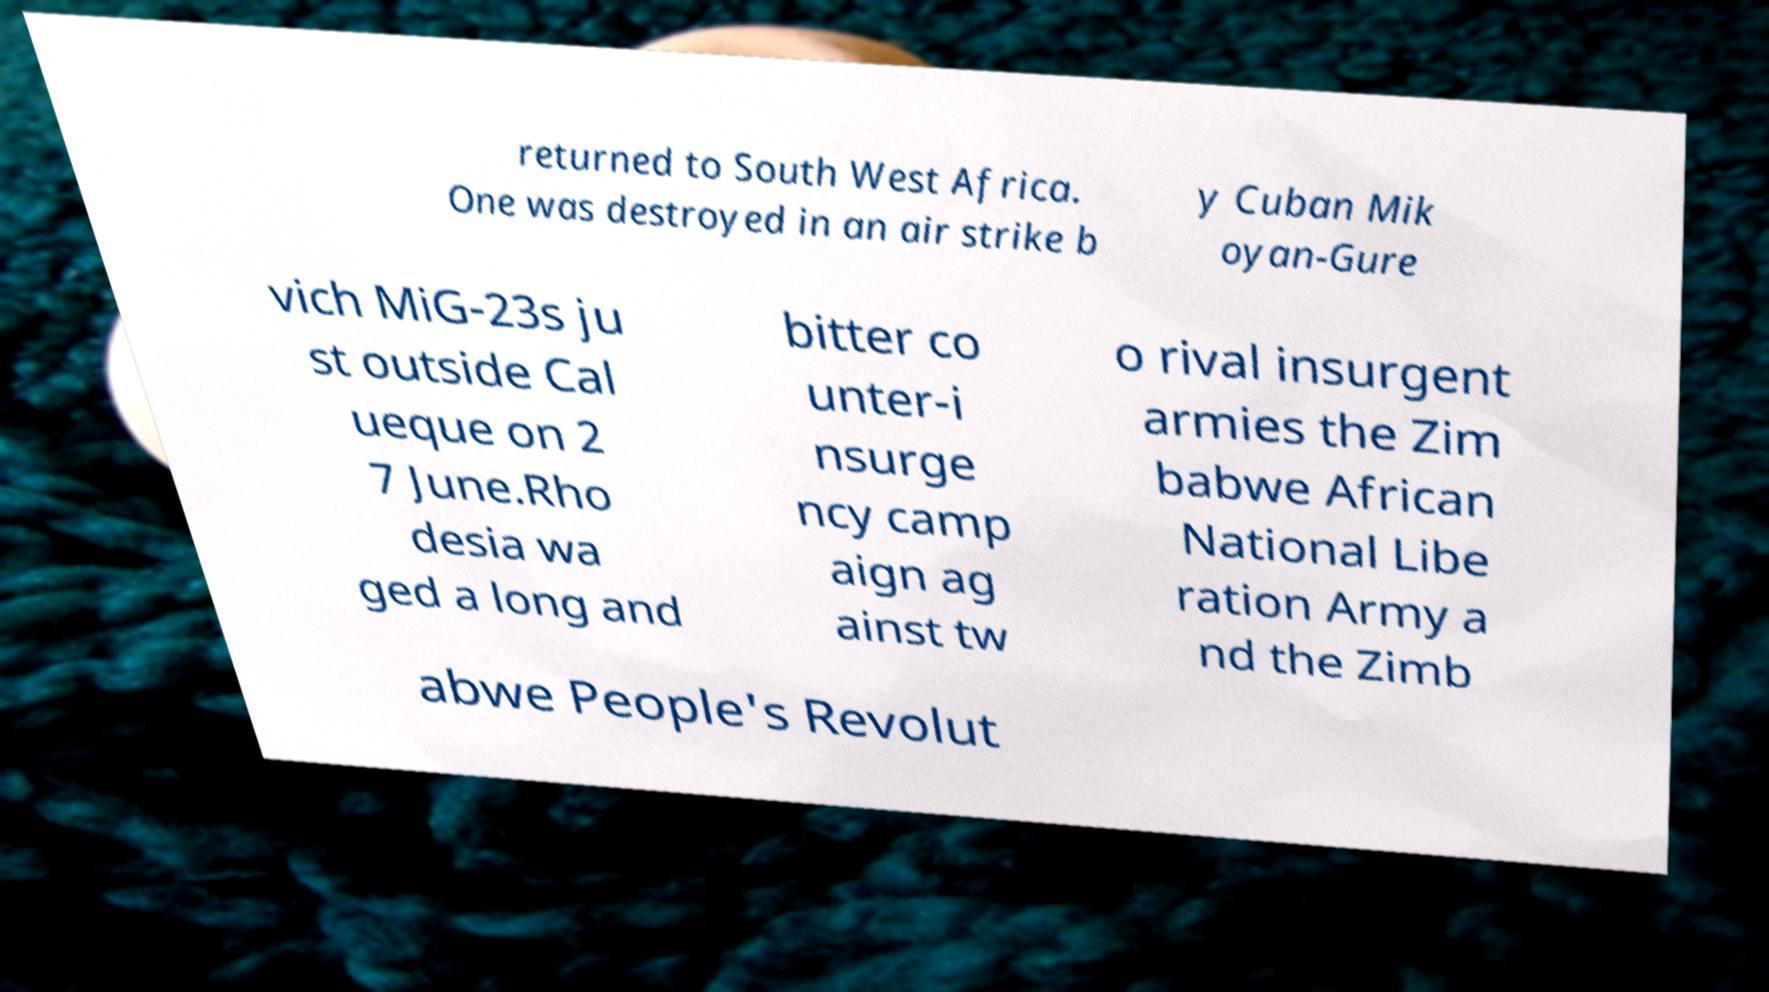Could you assist in decoding the text presented in this image and type it out clearly? returned to South West Africa. One was destroyed in an air strike b y Cuban Mik oyan-Gure vich MiG-23s ju st outside Cal ueque on 2 7 June.Rho desia wa ged a long and bitter co unter-i nsurge ncy camp aign ag ainst tw o rival insurgent armies the Zim babwe African National Libe ration Army a nd the Zimb abwe People's Revolut 